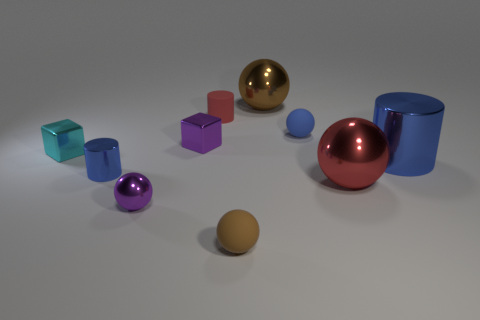There is another brown thing that is the same shape as the big brown metal object; what size is it?
Make the answer very short. Small. The other metal object that is the same shape as the tiny blue shiny thing is what color?
Offer a terse response. Blue. What number of other things are the same material as the cyan cube?
Offer a terse response. 6. Is the brown shiny object the same size as the cyan metal thing?
Ensure brevity in your answer.  No. How many objects are matte things that are behind the red metallic thing or cyan metal blocks?
Your answer should be very brief. 3. What is the material of the small sphere that is left of the purple cube behind the small metal sphere?
Offer a terse response. Metal. Are there any large brown matte objects that have the same shape as the tiny brown matte thing?
Keep it short and to the point. No. There is a red cylinder; is its size the same as the blue metallic thing that is in front of the large shiny cylinder?
Ensure brevity in your answer.  Yes. What number of objects are either blue cylinders that are on the right side of the small purple ball or purple shiny objects in front of the small blue ball?
Offer a very short reply. 3. Are there more red metal spheres to the left of the small blue shiny thing than matte things?
Provide a succinct answer. No. 